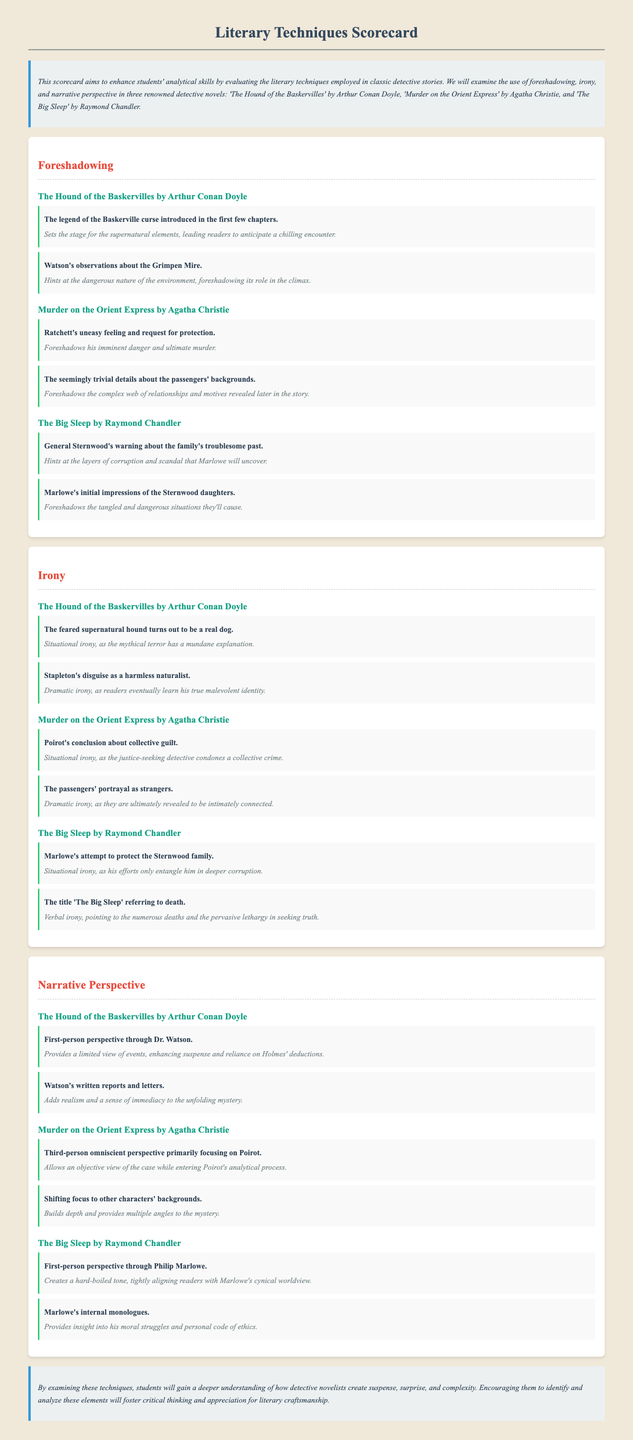What are the three detective novels examined in the scorecard? The scorecard evaluates 'The Hound of the Baskervilles', 'Murder on the Orient Express', and 'The Big Sleep'.
Answer: 'The Hound of the Baskervilles', 'Murder on the Orient Express', 'The Big Sleep' Which literary technique is associated with Dr. Watson's observations in 'The Hound of the Baskervilles'? Watson's observations hint at the dangerous nature of the environment, foreshadowing its role in the climax, linked to the technique of foreshadowing.
Answer: Foreshadowing In 'Murder on the Orient Express', what does Poirot conclude regarding the passengers? Poirot's conclusion about collective guilt indicates a situational irony, as he condones a collective crime despite being a justice-seeking detective.
Answer: Collective guilt Who provides the first-person perspective in 'The Big Sleep'? The first-person perspective is provided through Philip Marlowe, giving readers insight into his worldview.
Answer: Philip Marlowe What type of irony is found when the feared supernatural hound is revealed? The situation where the mythical terror is explained as a real dog is an example of situational irony.
Answer: Situational irony What narrative perspective is primarily used in 'Murder on the Orient Express'? The scorecard notes that the narrative perspective is a third-person omniscient perspective primarily focusing on Poirot.
Answer: Third-person omniscient Which character's disguise reveals dramatic irony in 'The Hound of the Baskervilles'? Stapleton's disguise as a harmless naturalist unveils his true malevolent identity, making it an example of dramatic irony.
Answer: Stapleton What is the role of Watson's written reports in 'The Hound of the Baskervilles'? Watson's reports add realism and immediacy to the unfolding mystery through his firsthand experience.
Answer: Adds realism What literary technique is highlighted by the initial impressions of the Sternwood daughters in 'The Big Sleep'? Marlowe's initial impressions of the Sternwood daughters foreshadow the tangled and dangerous situations they'll cause.
Answer: Foreshadowing 